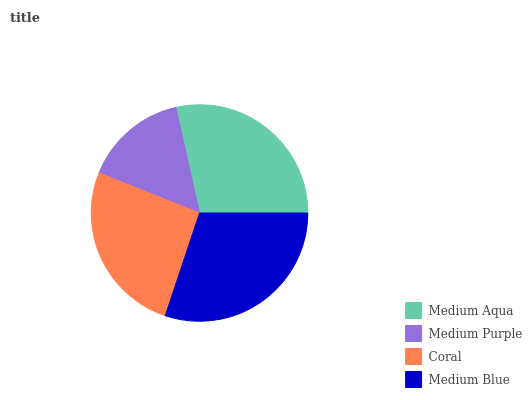Is Medium Purple the minimum?
Answer yes or no. Yes. Is Medium Blue the maximum?
Answer yes or no. Yes. Is Coral the minimum?
Answer yes or no. No. Is Coral the maximum?
Answer yes or no. No. Is Coral greater than Medium Purple?
Answer yes or no. Yes. Is Medium Purple less than Coral?
Answer yes or no. Yes. Is Medium Purple greater than Coral?
Answer yes or no. No. Is Coral less than Medium Purple?
Answer yes or no. No. Is Medium Aqua the high median?
Answer yes or no. Yes. Is Coral the low median?
Answer yes or no. Yes. Is Coral the high median?
Answer yes or no. No. Is Medium Aqua the low median?
Answer yes or no. No. 